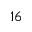Convert formula to latex. <formula><loc_0><loc_0><loc_500><loc_500>1 6</formula> 